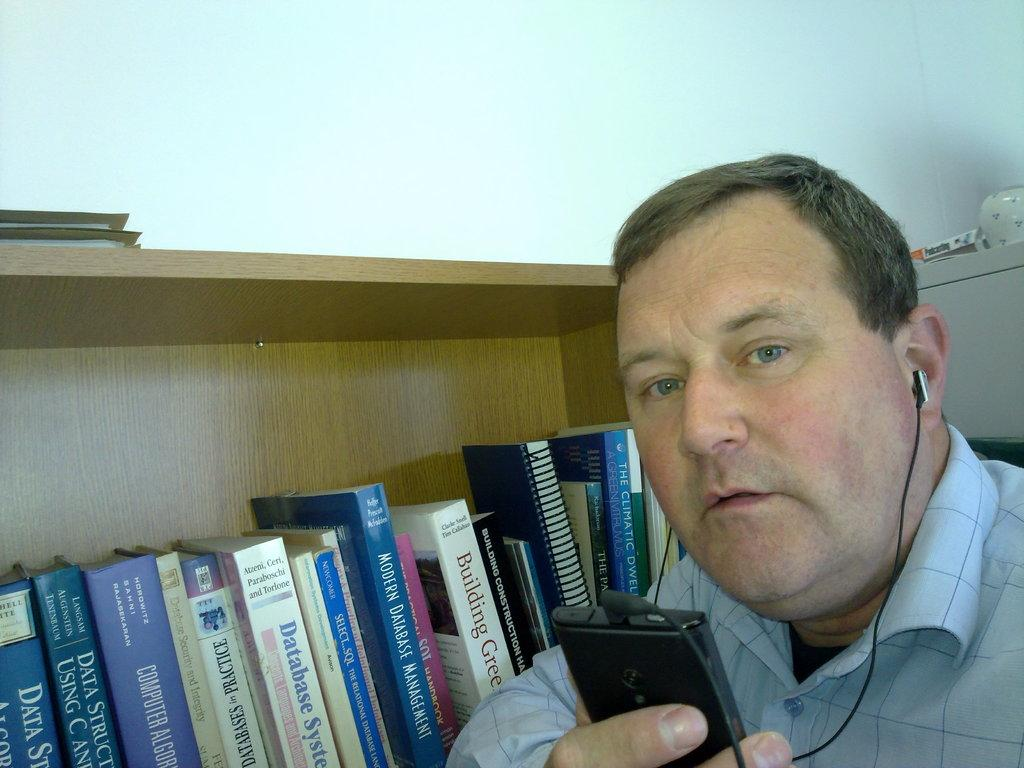<image>
Share a concise interpretation of the image provided. Modern Database Management is written on the spine of this book. 